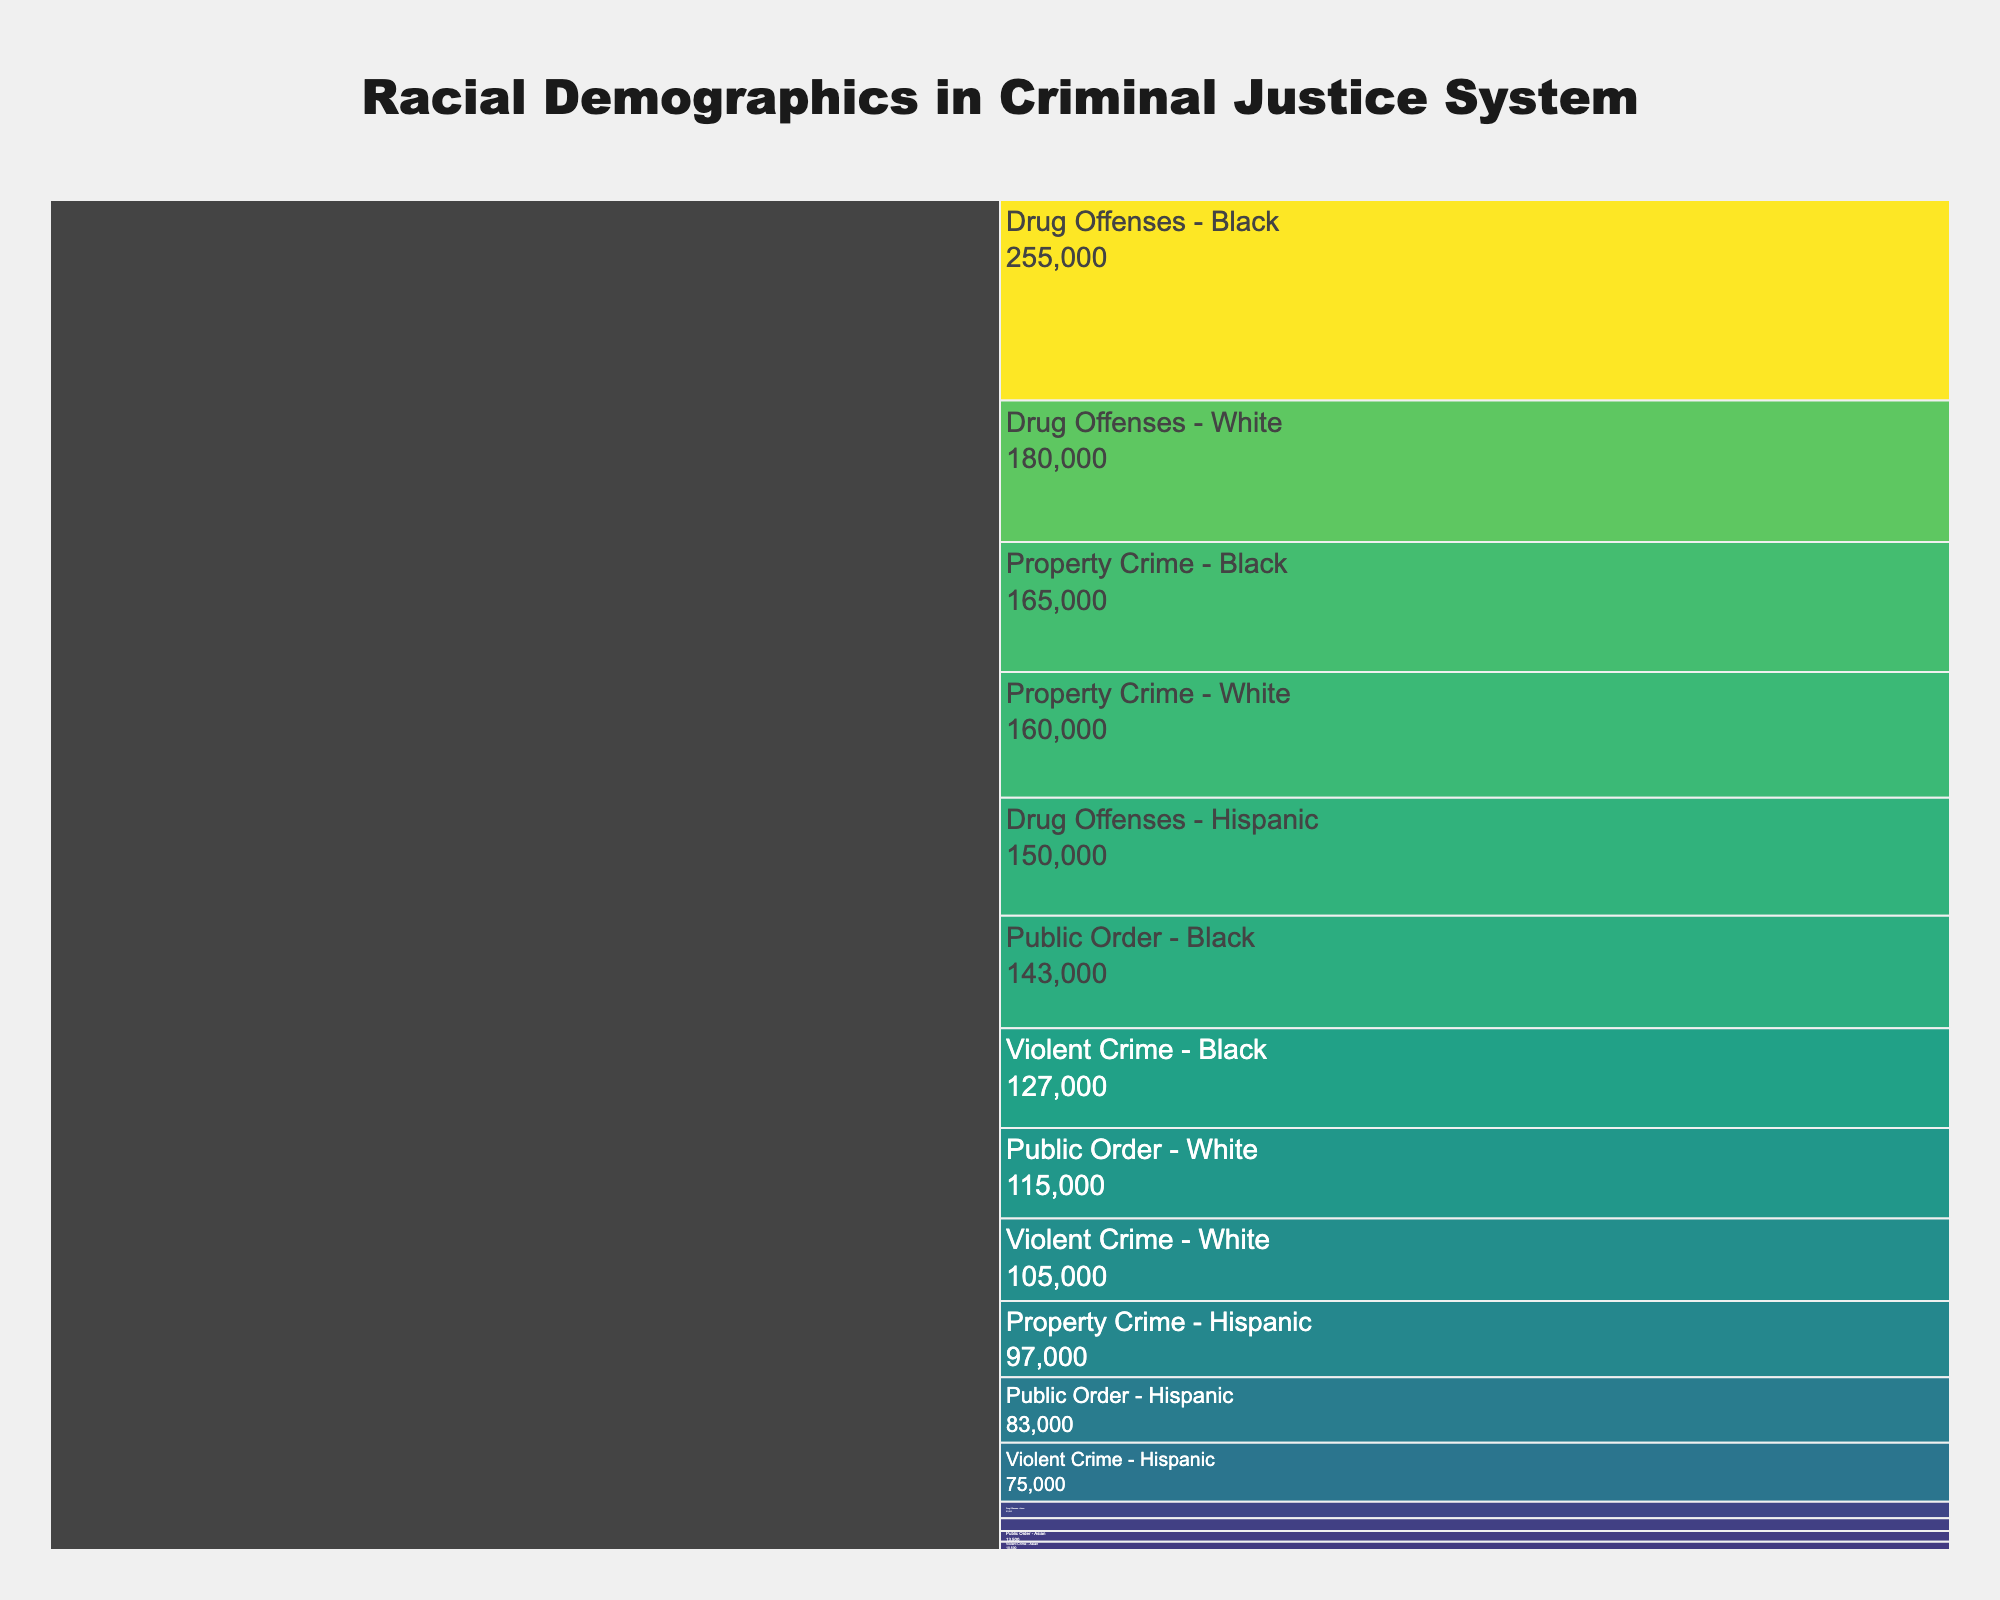what is the title of the figure? The title is usually positioned at the top of the figure. In this case, it's "Racial Demographics in Criminal Justice System."
Answer: Racial Demographics in Criminal Justice System Which crime category has the highest number of arrests for Black individuals? The chart allows us to see different crime categories and racial groups. By observing the sections labeled for Black individuals, we find that "Drug Offenses" has the highest number of arrests at 100,000.
Answer: Drug Offenses How many total values (sum of Arrests, Convictions, and Incarcerations) are there for Asians in Property Crime? Locate the section labeled "Property Crime - Asian." The values for this section are 8000 (Arrests), 5500 (Convictions), and 3000 (Incarcerations). Adding these together, we get 8000 + 5500 + 3000 = 16500.
Answer: 16500 Compare the number of incarcerations between Hispanics and Whites in Violent Crimes. Who has more, and by how much? For "Violent Crime," Hispanics have 2000 incarcerations, and Whites have 25000. Thus, Whites have more incarcerations by 25000 - 2000 = 23000.
Answer: Whites by 23000 What is the average number of convictions for all races in Public Order offenses? To calculate the average, first find the number of convictions for each race in Public Order offenses: White (40000), Black (48000), Hispanic (28000), and Asian (4500). Sum these values: 40000 + 48000 + 28000 + 4500 = 120500. Divide by the number of races (4), so 120500 / 4 = 30125.
Answer: 30125 Which racial group has the highest total value in Drug Offenses, and what is that value? Observing the sections under "Drug Offenses," Black individuals have the highest total value of 100000 (Arrests) + 85000 (Convictions) + 70000 (Incarcerations) = 255000.
Answer: Black, 255000 What are the total arrests for Property Crime across all races? To find this, sum all the arrests in the "Property Crime" category: Whites (70000), Blacks (65000), Hispanics (40000), and Asians (8000). So, 70000 + 65000 + 40000 + 8000 = 183000.
Answer: 183000 Which race has the lowest number of convictions for Public Order offenses, and what is that number? By comparing the conviction numbers under "Public Order" for different races, Asians have the lowest number with 4500 convictions.
Answer: Asian, 4500 In which crime category do Hispanics have the highest number of incarcerations? Looking at the incarcerations for Hispanics across different categories, "Drug Offenses" has the highest number with 40000 incarcerations.
Answer: Drug Offenses What's the difference between the total values (sum of Arrests, Convictions, and Incarcerations) for Blacks and Whites in Violent Crimes? For Blacks in Violent Crimes: 50000 (Arrests) + 42000 (Convictions) + 35000 (Incarcerations) = 127000. For Whites in Violent Crimes: 45000 (Arrests) + 35000 (Convictions) + 25000 (Incarcerations) = 105000. The difference is 127000 - 105000 = 22000.
Answer: 22000 